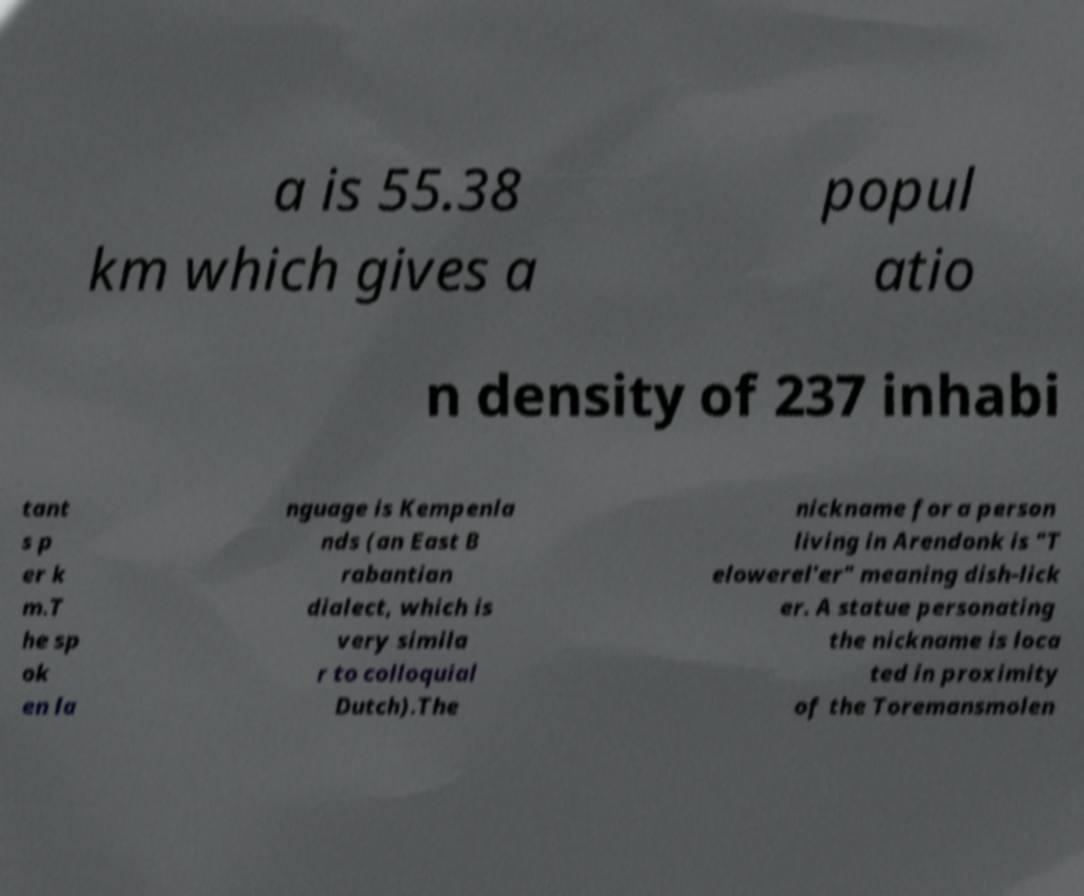Please read and relay the text visible in this image. What does it say? a is 55.38 km which gives a popul atio n density of 237 inhabi tant s p er k m.T he sp ok en la nguage is Kempenla nds (an East B rabantian dialect, which is very simila r to colloquial Dutch).The nickname for a person living in Arendonk is "T elowerel'er" meaning dish-lick er. A statue personating the nickname is loca ted in proximity of the Toremansmolen 